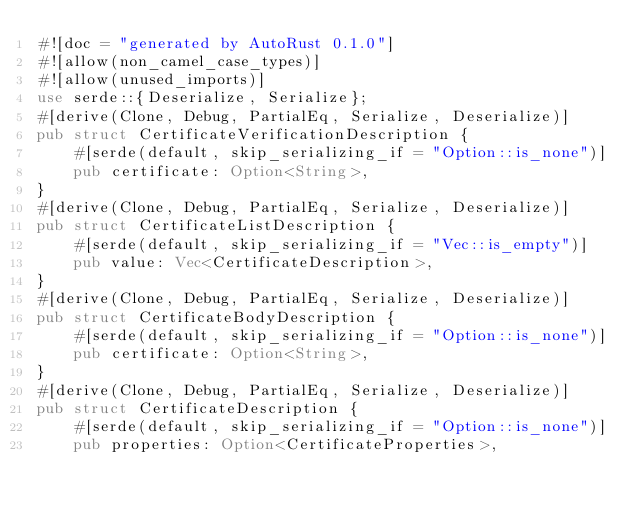Convert code to text. <code><loc_0><loc_0><loc_500><loc_500><_Rust_>#![doc = "generated by AutoRust 0.1.0"]
#![allow(non_camel_case_types)]
#![allow(unused_imports)]
use serde::{Deserialize, Serialize};
#[derive(Clone, Debug, PartialEq, Serialize, Deserialize)]
pub struct CertificateVerificationDescription {
    #[serde(default, skip_serializing_if = "Option::is_none")]
    pub certificate: Option<String>,
}
#[derive(Clone, Debug, PartialEq, Serialize, Deserialize)]
pub struct CertificateListDescription {
    #[serde(default, skip_serializing_if = "Vec::is_empty")]
    pub value: Vec<CertificateDescription>,
}
#[derive(Clone, Debug, PartialEq, Serialize, Deserialize)]
pub struct CertificateBodyDescription {
    #[serde(default, skip_serializing_if = "Option::is_none")]
    pub certificate: Option<String>,
}
#[derive(Clone, Debug, PartialEq, Serialize, Deserialize)]
pub struct CertificateDescription {
    #[serde(default, skip_serializing_if = "Option::is_none")]
    pub properties: Option<CertificateProperties>,</code> 